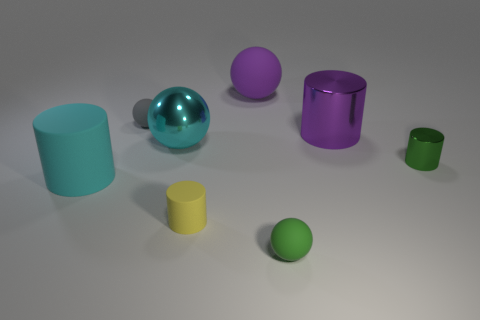Subtract all tiny gray rubber balls. How many balls are left? 3 Add 1 big purple metallic cylinders. How many objects exist? 9 Subtract all yellow cylinders. How many cylinders are left? 3 Subtract 0 red cylinders. How many objects are left? 8 Subtract 1 cylinders. How many cylinders are left? 3 Subtract all green cylinders. Subtract all cyan blocks. How many cylinders are left? 3 Subtract all red cylinders. How many cyan balls are left? 1 Subtract all small green cylinders. Subtract all purple objects. How many objects are left? 5 Add 1 small green rubber balls. How many small green rubber balls are left? 2 Add 6 green matte objects. How many green matte objects exist? 7 